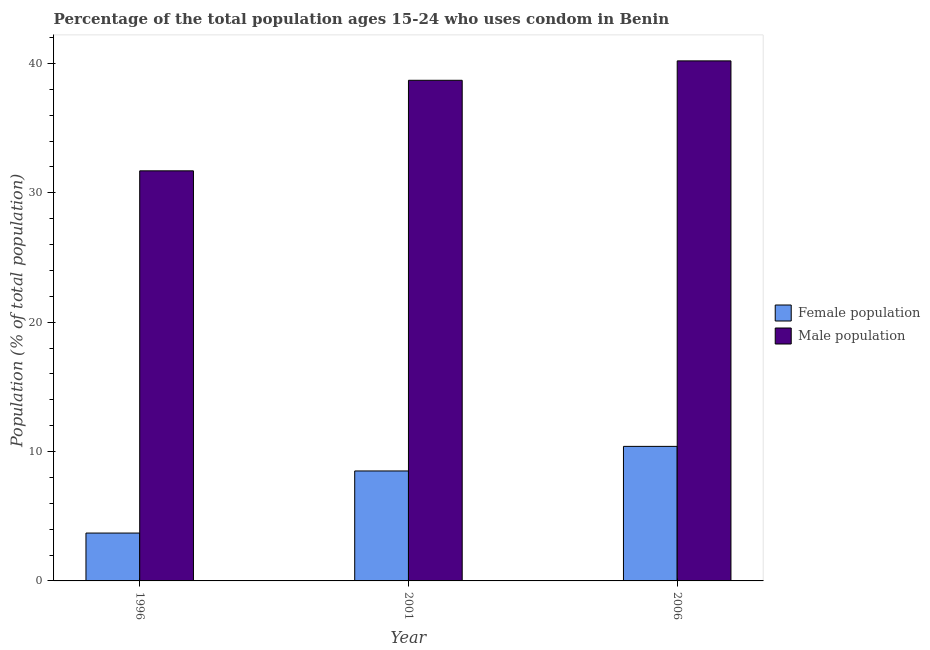How many different coloured bars are there?
Ensure brevity in your answer.  2. How many bars are there on the 1st tick from the left?
Provide a short and direct response. 2. In how many cases, is the number of bars for a given year not equal to the number of legend labels?
Provide a succinct answer. 0. What is the female population in 2006?
Give a very brief answer. 10.4. Across all years, what is the maximum female population?
Give a very brief answer. 10.4. Across all years, what is the minimum male population?
Provide a short and direct response. 31.7. What is the total female population in the graph?
Offer a very short reply. 22.6. What is the difference between the male population in 2001 and that in 2006?
Keep it short and to the point. -1.5. What is the average male population per year?
Your answer should be very brief. 36.87. In how many years, is the female population greater than 40 %?
Offer a terse response. 0. What is the ratio of the male population in 1996 to that in 2001?
Make the answer very short. 0.82. What is the difference between the highest and the second highest male population?
Your answer should be very brief. 1.5. What is the difference between the highest and the lowest female population?
Provide a succinct answer. 6.7. In how many years, is the male population greater than the average male population taken over all years?
Provide a short and direct response. 2. Is the sum of the female population in 2001 and 2006 greater than the maximum male population across all years?
Offer a terse response. Yes. What does the 2nd bar from the left in 1996 represents?
Provide a succinct answer. Male population. What does the 2nd bar from the right in 1996 represents?
Your answer should be compact. Female population. How many bars are there?
Offer a terse response. 6. Are all the bars in the graph horizontal?
Give a very brief answer. No. Does the graph contain any zero values?
Provide a succinct answer. No. Where does the legend appear in the graph?
Your answer should be compact. Center right. How many legend labels are there?
Keep it short and to the point. 2. How are the legend labels stacked?
Offer a terse response. Vertical. What is the title of the graph?
Keep it short and to the point. Percentage of the total population ages 15-24 who uses condom in Benin. Does "Money lenders" appear as one of the legend labels in the graph?
Your response must be concise. No. What is the label or title of the Y-axis?
Provide a short and direct response. Population (% of total population) . What is the Population (% of total population)  of Male population in 1996?
Keep it short and to the point. 31.7. What is the Population (% of total population)  of Female population in 2001?
Your answer should be compact. 8.5. What is the Population (% of total population)  of Male population in 2001?
Your response must be concise. 38.7. What is the Population (% of total population)  of Female population in 2006?
Keep it short and to the point. 10.4. What is the Population (% of total population)  of Male population in 2006?
Keep it short and to the point. 40.2. Across all years, what is the maximum Population (% of total population)  of Male population?
Make the answer very short. 40.2. Across all years, what is the minimum Population (% of total population)  in Female population?
Ensure brevity in your answer.  3.7. Across all years, what is the minimum Population (% of total population)  in Male population?
Your answer should be very brief. 31.7. What is the total Population (% of total population)  of Female population in the graph?
Offer a terse response. 22.6. What is the total Population (% of total population)  in Male population in the graph?
Give a very brief answer. 110.6. What is the difference between the Population (% of total population)  of Female population in 1996 and that in 2001?
Your answer should be compact. -4.8. What is the difference between the Population (% of total population)  of Male population in 1996 and that in 2001?
Offer a very short reply. -7. What is the difference between the Population (% of total population)  in Female population in 1996 and that in 2006?
Ensure brevity in your answer.  -6.7. What is the difference between the Population (% of total population)  in Female population in 2001 and that in 2006?
Offer a terse response. -1.9. What is the difference between the Population (% of total population)  in Male population in 2001 and that in 2006?
Ensure brevity in your answer.  -1.5. What is the difference between the Population (% of total population)  of Female population in 1996 and the Population (% of total population)  of Male population in 2001?
Give a very brief answer. -35. What is the difference between the Population (% of total population)  in Female population in 1996 and the Population (% of total population)  in Male population in 2006?
Provide a succinct answer. -36.5. What is the difference between the Population (% of total population)  of Female population in 2001 and the Population (% of total population)  of Male population in 2006?
Your answer should be very brief. -31.7. What is the average Population (% of total population)  of Female population per year?
Ensure brevity in your answer.  7.53. What is the average Population (% of total population)  of Male population per year?
Give a very brief answer. 36.87. In the year 2001, what is the difference between the Population (% of total population)  of Female population and Population (% of total population)  of Male population?
Provide a short and direct response. -30.2. In the year 2006, what is the difference between the Population (% of total population)  of Female population and Population (% of total population)  of Male population?
Provide a short and direct response. -29.8. What is the ratio of the Population (% of total population)  of Female population in 1996 to that in 2001?
Give a very brief answer. 0.44. What is the ratio of the Population (% of total population)  in Male population in 1996 to that in 2001?
Ensure brevity in your answer.  0.82. What is the ratio of the Population (% of total population)  in Female population in 1996 to that in 2006?
Give a very brief answer. 0.36. What is the ratio of the Population (% of total population)  in Male population in 1996 to that in 2006?
Your answer should be compact. 0.79. What is the ratio of the Population (% of total population)  of Female population in 2001 to that in 2006?
Your response must be concise. 0.82. What is the ratio of the Population (% of total population)  in Male population in 2001 to that in 2006?
Give a very brief answer. 0.96. What is the difference between the highest and the second highest Population (% of total population)  of Male population?
Provide a short and direct response. 1.5. What is the difference between the highest and the lowest Population (% of total population)  in Female population?
Your answer should be very brief. 6.7. 